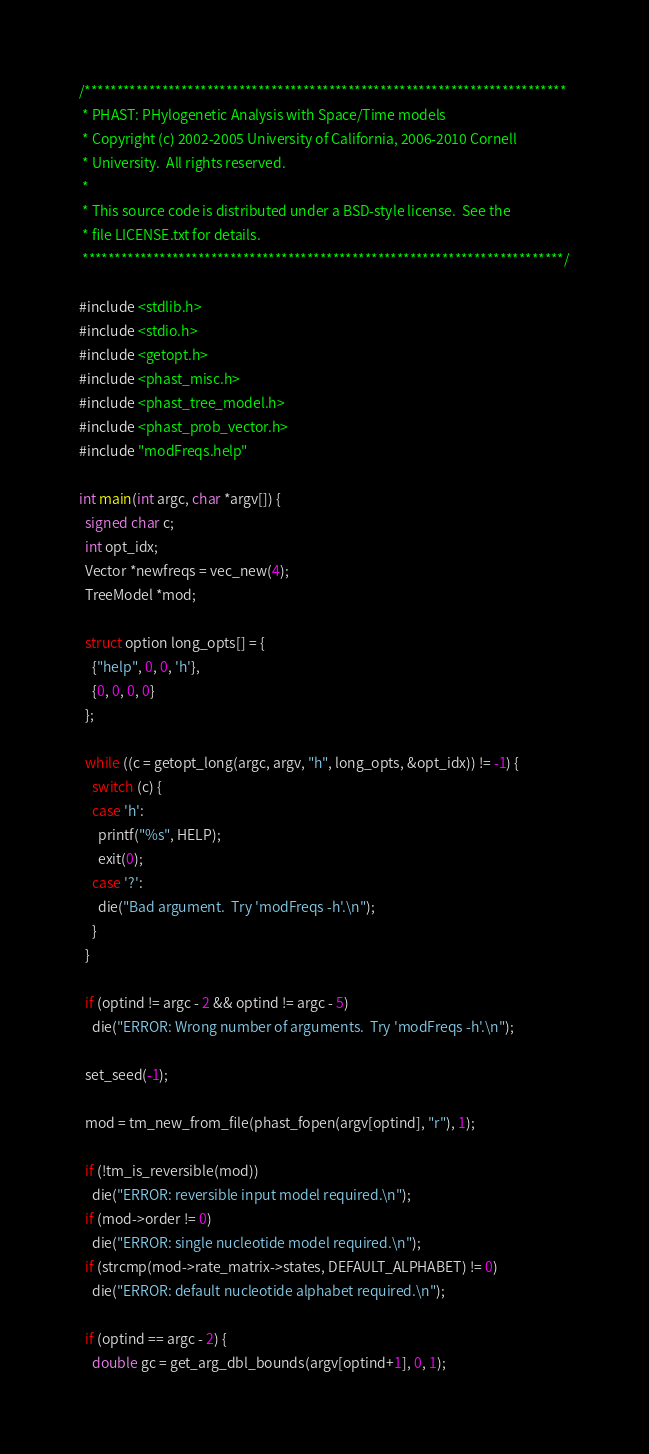<code> <loc_0><loc_0><loc_500><loc_500><_C_>/***************************************************************************
 * PHAST: PHylogenetic Analysis with Space/Time models
 * Copyright (c) 2002-2005 University of California, 2006-2010 Cornell 
 * University.  All rights reserved.
 *
 * This source code is distributed under a BSD-style license.  See the
 * file LICENSE.txt for details.
 ***************************************************************************/

#include <stdlib.h>
#include <stdio.h>
#include <getopt.h>
#include <phast_misc.h>
#include <phast_tree_model.h>
#include <phast_prob_vector.h>
#include "modFreqs.help"

int main(int argc, char *argv[]) {
  signed char c;
  int opt_idx;
  Vector *newfreqs = vec_new(4);
  TreeModel *mod;

  struct option long_opts[] = {
    {"help", 0, 0, 'h'},
    {0, 0, 0, 0}
  };

  while ((c = getopt_long(argc, argv, "h", long_opts, &opt_idx)) != -1) {
    switch (c) {
    case 'h':
      printf("%s", HELP);
      exit(0);
    case '?':
      die("Bad argument.  Try 'modFreqs -h'.\n");
    }
  }

  if (optind != argc - 2 && optind != argc - 5) 
    die("ERROR: Wrong number of arguments.  Try 'modFreqs -h'.\n");

  set_seed(-1);

  mod = tm_new_from_file(phast_fopen(argv[optind], "r"), 1);

  if (!tm_is_reversible(mod)) 
    die("ERROR: reversible input model required.\n");
  if (mod->order != 0)
    die("ERROR: single nucleotide model required.\n");
  if (strcmp(mod->rate_matrix->states, DEFAULT_ALPHABET) != 0)
    die("ERROR: default nucleotide alphabet required.\n");

  if (optind == argc - 2) {
    double gc = get_arg_dbl_bounds(argv[optind+1], 0, 1);</code> 